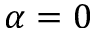<formula> <loc_0><loc_0><loc_500><loc_500>\alpha = 0</formula> 